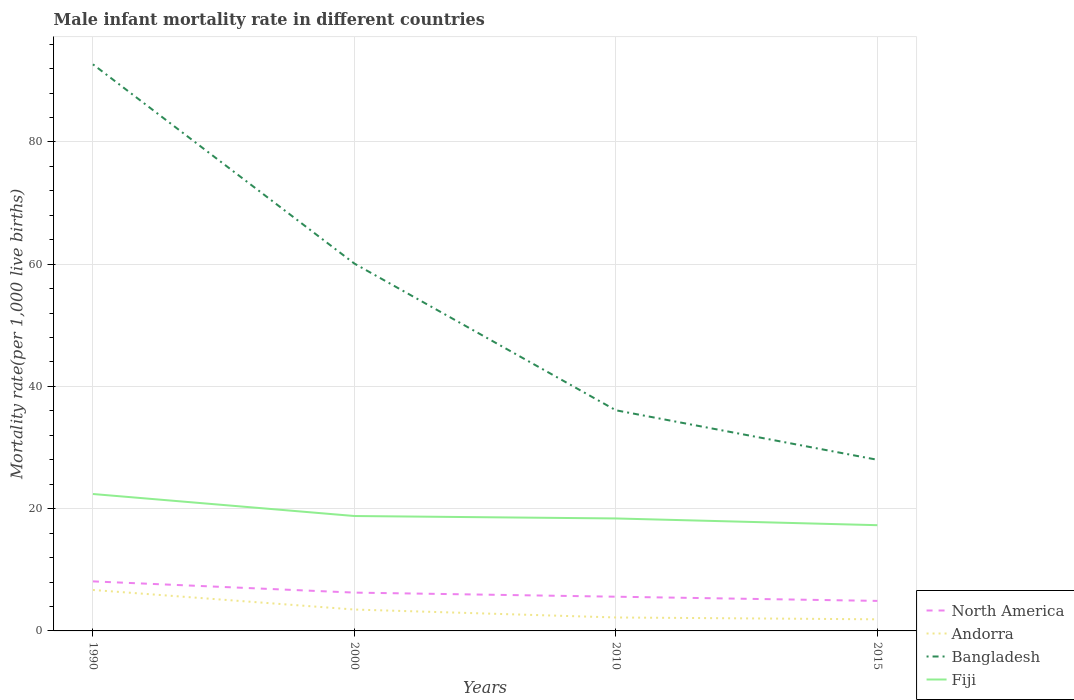Does the line corresponding to Fiji intersect with the line corresponding to Bangladesh?
Provide a succinct answer. No. In which year was the male infant mortality rate in Andorra maximum?
Keep it short and to the point. 2015. What is the total male infant mortality rate in Andorra in the graph?
Provide a succinct answer. 1.3. What is the difference between the highest and the second highest male infant mortality rate in Fiji?
Provide a short and direct response. 5.1. How many years are there in the graph?
Provide a short and direct response. 4. What is the title of the graph?
Keep it short and to the point. Male infant mortality rate in different countries. What is the label or title of the X-axis?
Offer a very short reply. Years. What is the label or title of the Y-axis?
Provide a short and direct response. Mortality rate(per 1,0 live births). What is the Mortality rate(per 1,000 live births) of North America in 1990?
Ensure brevity in your answer.  8.11. What is the Mortality rate(per 1,000 live births) of Bangladesh in 1990?
Ensure brevity in your answer.  92.7. What is the Mortality rate(per 1,000 live births) of Fiji in 1990?
Keep it short and to the point. 22.4. What is the Mortality rate(per 1,000 live births) in North America in 2000?
Give a very brief answer. 6.27. What is the Mortality rate(per 1,000 live births) of Andorra in 2000?
Offer a terse response. 3.5. What is the Mortality rate(per 1,000 live births) of Bangladesh in 2000?
Provide a succinct answer. 60.1. What is the Mortality rate(per 1,000 live births) in Fiji in 2000?
Your answer should be very brief. 18.8. What is the Mortality rate(per 1,000 live births) of North America in 2010?
Your answer should be compact. 5.6. What is the Mortality rate(per 1,000 live births) of Andorra in 2010?
Give a very brief answer. 2.2. What is the Mortality rate(per 1,000 live births) of Bangladesh in 2010?
Keep it short and to the point. 36.1. What is the Mortality rate(per 1,000 live births) in North America in 2015?
Your response must be concise. 4.91. What is the Mortality rate(per 1,000 live births) in Bangladesh in 2015?
Give a very brief answer. 28. What is the Mortality rate(per 1,000 live births) of Fiji in 2015?
Offer a terse response. 17.3. Across all years, what is the maximum Mortality rate(per 1,000 live births) of North America?
Provide a succinct answer. 8.11. Across all years, what is the maximum Mortality rate(per 1,000 live births) of Andorra?
Provide a short and direct response. 6.7. Across all years, what is the maximum Mortality rate(per 1,000 live births) in Bangladesh?
Offer a terse response. 92.7. Across all years, what is the maximum Mortality rate(per 1,000 live births) in Fiji?
Offer a very short reply. 22.4. Across all years, what is the minimum Mortality rate(per 1,000 live births) in North America?
Offer a very short reply. 4.91. Across all years, what is the minimum Mortality rate(per 1,000 live births) in Andorra?
Ensure brevity in your answer.  1.9. Across all years, what is the minimum Mortality rate(per 1,000 live births) in Bangladesh?
Keep it short and to the point. 28. What is the total Mortality rate(per 1,000 live births) of North America in the graph?
Keep it short and to the point. 24.89. What is the total Mortality rate(per 1,000 live births) of Bangladesh in the graph?
Make the answer very short. 216.9. What is the total Mortality rate(per 1,000 live births) of Fiji in the graph?
Offer a terse response. 76.9. What is the difference between the Mortality rate(per 1,000 live births) of North America in 1990 and that in 2000?
Provide a short and direct response. 1.84. What is the difference between the Mortality rate(per 1,000 live births) in Andorra in 1990 and that in 2000?
Offer a very short reply. 3.2. What is the difference between the Mortality rate(per 1,000 live births) of Bangladesh in 1990 and that in 2000?
Ensure brevity in your answer.  32.6. What is the difference between the Mortality rate(per 1,000 live births) in North America in 1990 and that in 2010?
Offer a very short reply. 2.51. What is the difference between the Mortality rate(per 1,000 live births) in Andorra in 1990 and that in 2010?
Your answer should be compact. 4.5. What is the difference between the Mortality rate(per 1,000 live births) of Bangladesh in 1990 and that in 2010?
Provide a short and direct response. 56.6. What is the difference between the Mortality rate(per 1,000 live births) in North America in 1990 and that in 2015?
Ensure brevity in your answer.  3.19. What is the difference between the Mortality rate(per 1,000 live births) in Bangladesh in 1990 and that in 2015?
Offer a very short reply. 64.7. What is the difference between the Mortality rate(per 1,000 live births) of North America in 2000 and that in 2010?
Give a very brief answer. 0.67. What is the difference between the Mortality rate(per 1,000 live births) of Andorra in 2000 and that in 2010?
Provide a succinct answer. 1.3. What is the difference between the Mortality rate(per 1,000 live births) in Bangladesh in 2000 and that in 2010?
Make the answer very short. 24. What is the difference between the Mortality rate(per 1,000 live births) of Fiji in 2000 and that in 2010?
Offer a terse response. 0.4. What is the difference between the Mortality rate(per 1,000 live births) of North America in 2000 and that in 2015?
Keep it short and to the point. 1.36. What is the difference between the Mortality rate(per 1,000 live births) in Andorra in 2000 and that in 2015?
Provide a succinct answer. 1.6. What is the difference between the Mortality rate(per 1,000 live births) in Bangladesh in 2000 and that in 2015?
Your answer should be very brief. 32.1. What is the difference between the Mortality rate(per 1,000 live births) of North America in 2010 and that in 2015?
Offer a very short reply. 0.69. What is the difference between the Mortality rate(per 1,000 live births) in Andorra in 2010 and that in 2015?
Your answer should be very brief. 0.3. What is the difference between the Mortality rate(per 1,000 live births) of North America in 1990 and the Mortality rate(per 1,000 live births) of Andorra in 2000?
Your response must be concise. 4.61. What is the difference between the Mortality rate(per 1,000 live births) of North America in 1990 and the Mortality rate(per 1,000 live births) of Bangladesh in 2000?
Ensure brevity in your answer.  -51.99. What is the difference between the Mortality rate(per 1,000 live births) in North America in 1990 and the Mortality rate(per 1,000 live births) in Fiji in 2000?
Make the answer very short. -10.69. What is the difference between the Mortality rate(per 1,000 live births) of Andorra in 1990 and the Mortality rate(per 1,000 live births) of Bangladesh in 2000?
Provide a succinct answer. -53.4. What is the difference between the Mortality rate(per 1,000 live births) of Bangladesh in 1990 and the Mortality rate(per 1,000 live births) of Fiji in 2000?
Offer a very short reply. 73.9. What is the difference between the Mortality rate(per 1,000 live births) in North America in 1990 and the Mortality rate(per 1,000 live births) in Andorra in 2010?
Your answer should be compact. 5.91. What is the difference between the Mortality rate(per 1,000 live births) in North America in 1990 and the Mortality rate(per 1,000 live births) in Bangladesh in 2010?
Offer a terse response. -27.99. What is the difference between the Mortality rate(per 1,000 live births) of North America in 1990 and the Mortality rate(per 1,000 live births) of Fiji in 2010?
Keep it short and to the point. -10.29. What is the difference between the Mortality rate(per 1,000 live births) in Andorra in 1990 and the Mortality rate(per 1,000 live births) in Bangladesh in 2010?
Provide a short and direct response. -29.4. What is the difference between the Mortality rate(per 1,000 live births) of Andorra in 1990 and the Mortality rate(per 1,000 live births) of Fiji in 2010?
Your answer should be compact. -11.7. What is the difference between the Mortality rate(per 1,000 live births) in Bangladesh in 1990 and the Mortality rate(per 1,000 live births) in Fiji in 2010?
Provide a succinct answer. 74.3. What is the difference between the Mortality rate(per 1,000 live births) of North America in 1990 and the Mortality rate(per 1,000 live births) of Andorra in 2015?
Provide a succinct answer. 6.21. What is the difference between the Mortality rate(per 1,000 live births) of North America in 1990 and the Mortality rate(per 1,000 live births) of Bangladesh in 2015?
Make the answer very short. -19.89. What is the difference between the Mortality rate(per 1,000 live births) of North America in 1990 and the Mortality rate(per 1,000 live births) of Fiji in 2015?
Give a very brief answer. -9.19. What is the difference between the Mortality rate(per 1,000 live births) of Andorra in 1990 and the Mortality rate(per 1,000 live births) of Bangladesh in 2015?
Make the answer very short. -21.3. What is the difference between the Mortality rate(per 1,000 live births) in Andorra in 1990 and the Mortality rate(per 1,000 live births) in Fiji in 2015?
Provide a short and direct response. -10.6. What is the difference between the Mortality rate(per 1,000 live births) of Bangladesh in 1990 and the Mortality rate(per 1,000 live births) of Fiji in 2015?
Provide a succinct answer. 75.4. What is the difference between the Mortality rate(per 1,000 live births) in North America in 2000 and the Mortality rate(per 1,000 live births) in Andorra in 2010?
Make the answer very short. 4.07. What is the difference between the Mortality rate(per 1,000 live births) in North America in 2000 and the Mortality rate(per 1,000 live births) in Bangladesh in 2010?
Make the answer very short. -29.83. What is the difference between the Mortality rate(per 1,000 live births) of North America in 2000 and the Mortality rate(per 1,000 live births) of Fiji in 2010?
Offer a very short reply. -12.13. What is the difference between the Mortality rate(per 1,000 live births) of Andorra in 2000 and the Mortality rate(per 1,000 live births) of Bangladesh in 2010?
Your answer should be very brief. -32.6. What is the difference between the Mortality rate(per 1,000 live births) of Andorra in 2000 and the Mortality rate(per 1,000 live births) of Fiji in 2010?
Your answer should be very brief. -14.9. What is the difference between the Mortality rate(per 1,000 live births) in Bangladesh in 2000 and the Mortality rate(per 1,000 live births) in Fiji in 2010?
Offer a very short reply. 41.7. What is the difference between the Mortality rate(per 1,000 live births) in North America in 2000 and the Mortality rate(per 1,000 live births) in Andorra in 2015?
Make the answer very short. 4.37. What is the difference between the Mortality rate(per 1,000 live births) in North America in 2000 and the Mortality rate(per 1,000 live births) in Bangladesh in 2015?
Give a very brief answer. -21.73. What is the difference between the Mortality rate(per 1,000 live births) of North America in 2000 and the Mortality rate(per 1,000 live births) of Fiji in 2015?
Keep it short and to the point. -11.03. What is the difference between the Mortality rate(per 1,000 live births) of Andorra in 2000 and the Mortality rate(per 1,000 live births) of Bangladesh in 2015?
Ensure brevity in your answer.  -24.5. What is the difference between the Mortality rate(per 1,000 live births) of Bangladesh in 2000 and the Mortality rate(per 1,000 live births) of Fiji in 2015?
Give a very brief answer. 42.8. What is the difference between the Mortality rate(per 1,000 live births) in North America in 2010 and the Mortality rate(per 1,000 live births) in Andorra in 2015?
Your answer should be very brief. 3.7. What is the difference between the Mortality rate(per 1,000 live births) in North America in 2010 and the Mortality rate(per 1,000 live births) in Bangladesh in 2015?
Keep it short and to the point. -22.4. What is the difference between the Mortality rate(per 1,000 live births) in North America in 2010 and the Mortality rate(per 1,000 live births) in Fiji in 2015?
Your response must be concise. -11.7. What is the difference between the Mortality rate(per 1,000 live births) of Andorra in 2010 and the Mortality rate(per 1,000 live births) of Bangladesh in 2015?
Your answer should be very brief. -25.8. What is the difference between the Mortality rate(per 1,000 live births) in Andorra in 2010 and the Mortality rate(per 1,000 live births) in Fiji in 2015?
Your answer should be compact. -15.1. What is the difference between the Mortality rate(per 1,000 live births) in Bangladesh in 2010 and the Mortality rate(per 1,000 live births) in Fiji in 2015?
Provide a short and direct response. 18.8. What is the average Mortality rate(per 1,000 live births) in North America per year?
Keep it short and to the point. 6.22. What is the average Mortality rate(per 1,000 live births) of Andorra per year?
Offer a very short reply. 3.58. What is the average Mortality rate(per 1,000 live births) of Bangladesh per year?
Offer a terse response. 54.23. What is the average Mortality rate(per 1,000 live births) of Fiji per year?
Make the answer very short. 19.23. In the year 1990, what is the difference between the Mortality rate(per 1,000 live births) of North America and Mortality rate(per 1,000 live births) of Andorra?
Provide a succinct answer. 1.41. In the year 1990, what is the difference between the Mortality rate(per 1,000 live births) of North America and Mortality rate(per 1,000 live births) of Bangladesh?
Offer a terse response. -84.59. In the year 1990, what is the difference between the Mortality rate(per 1,000 live births) of North America and Mortality rate(per 1,000 live births) of Fiji?
Your answer should be compact. -14.29. In the year 1990, what is the difference between the Mortality rate(per 1,000 live births) of Andorra and Mortality rate(per 1,000 live births) of Bangladesh?
Keep it short and to the point. -86. In the year 1990, what is the difference between the Mortality rate(per 1,000 live births) in Andorra and Mortality rate(per 1,000 live births) in Fiji?
Ensure brevity in your answer.  -15.7. In the year 1990, what is the difference between the Mortality rate(per 1,000 live births) of Bangladesh and Mortality rate(per 1,000 live births) of Fiji?
Ensure brevity in your answer.  70.3. In the year 2000, what is the difference between the Mortality rate(per 1,000 live births) of North America and Mortality rate(per 1,000 live births) of Andorra?
Make the answer very short. 2.77. In the year 2000, what is the difference between the Mortality rate(per 1,000 live births) in North America and Mortality rate(per 1,000 live births) in Bangladesh?
Keep it short and to the point. -53.83. In the year 2000, what is the difference between the Mortality rate(per 1,000 live births) of North America and Mortality rate(per 1,000 live births) of Fiji?
Your response must be concise. -12.53. In the year 2000, what is the difference between the Mortality rate(per 1,000 live births) in Andorra and Mortality rate(per 1,000 live births) in Bangladesh?
Your answer should be compact. -56.6. In the year 2000, what is the difference between the Mortality rate(per 1,000 live births) in Andorra and Mortality rate(per 1,000 live births) in Fiji?
Make the answer very short. -15.3. In the year 2000, what is the difference between the Mortality rate(per 1,000 live births) in Bangladesh and Mortality rate(per 1,000 live births) in Fiji?
Offer a very short reply. 41.3. In the year 2010, what is the difference between the Mortality rate(per 1,000 live births) in North America and Mortality rate(per 1,000 live births) in Andorra?
Your answer should be compact. 3.4. In the year 2010, what is the difference between the Mortality rate(per 1,000 live births) of North America and Mortality rate(per 1,000 live births) of Bangladesh?
Your answer should be compact. -30.5. In the year 2010, what is the difference between the Mortality rate(per 1,000 live births) of North America and Mortality rate(per 1,000 live births) of Fiji?
Make the answer very short. -12.8. In the year 2010, what is the difference between the Mortality rate(per 1,000 live births) of Andorra and Mortality rate(per 1,000 live births) of Bangladesh?
Offer a very short reply. -33.9. In the year 2010, what is the difference between the Mortality rate(per 1,000 live births) in Andorra and Mortality rate(per 1,000 live births) in Fiji?
Your answer should be compact. -16.2. In the year 2015, what is the difference between the Mortality rate(per 1,000 live births) in North America and Mortality rate(per 1,000 live births) in Andorra?
Your answer should be very brief. 3.01. In the year 2015, what is the difference between the Mortality rate(per 1,000 live births) of North America and Mortality rate(per 1,000 live births) of Bangladesh?
Provide a short and direct response. -23.09. In the year 2015, what is the difference between the Mortality rate(per 1,000 live births) in North America and Mortality rate(per 1,000 live births) in Fiji?
Ensure brevity in your answer.  -12.39. In the year 2015, what is the difference between the Mortality rate(per 1,000 live births) in Andorra and Mortality rate(per 1,000 live births) in Bangladesh?
Offer a terse response. -26.1. In the year 2015, what is the difference between the Mortality rate(per 1,000 live births) in Andorra and Mortality rate(per 1,000 live births) in Fiji?
Your answer should be very brief. -15.4. What is the ratio of the Mortality rate(per 1,000 live births) of North America in 1990 to that in 2000?
Your answer should be compact. 1.29. What is the ratio of the Mortality rate(per 1,000 live births) in Andorra in 1990 to that in 2000?
Offer a terse response. 1.91. What is the ratio of the Mortality rate(per 1,000 live births) of Bangladesh in 1990 to that in 2000?
Provide a succinct answer. 1.54. What is the ratio of the Mortality rate(per 1,000 live births) of Fiji in 1990 to that in 2000?
Offer a very short reply. 1.19. What is the ratio of the Mortality rate(per 1,000 live births) in North America in 1990 to that in 2010?
Ensure brevity in your answer.  1.45. What is the ratio of the Mortality rate(per 1,000 live births) in Andorra in 1990 to that in 2010?
Offer a very short reply. 3.05. What is the ratio of the Mortality rate(per 1,000 live births) in Bangladesh in 1990 to that in 2010?
Keep it short and to the point. 2.57. What is the ratio of the Mortality rate(per 1,000 live births) in Fiji in 1990 to that in 2010?
Keep it short and to the point. 1.22. What is the ratio of the Mortality rate(per 1,000 live births) of North America in 1990 to that in 2015?
Provide a succinct answer. 1.65. What is the ratio of the Mortality rate(per 1,000 live births) in Andorra in 1990 to that in 2015?
Offer a terse response. 3.53. What is the ratio of the Mortality rate(per 1,000 live births) in Bangladesh in 1990 to that in 2015?
Offer a very short reply. 3.31. What is the ratio of the Mortality rate(per 1,000 live births) of Fiji in 1990 to that in 2015?
Provide a succinct answer. 1.29. What is the ratio of the Mortality rate(per 1,000 live births) in North America in 2000 to that in 2010?
Keep it short and to the point. 1.12. What is the ratio of the Mortality rate(per 1,000 live births) in Andorra in 2000 to that in 2010?
Offer a very short reply. 1.59. What is the ratio of the Mortality rate(per 1,000 live births) of Bangladesh in 2000 to that in 2010?
Your answer should be very brief. 1.66. What is the ratio of the Mortality rate(per 1,000 live births) in Fiji in 2000 to that in 2010?
Give a very brief answer. 1.02. What is the ratio of the Mortality rate(per 1,000 live births) in North America in 2000 to that in 2015?
Provide a short and direct response. 1.28. What is the ratio of the Mortality rate(per 1,000 live births) in Andorra in 2000 to that in 2015?
Give a very brief answer. 1.84. What is the ratio of the Mortality rate(per 1,000 live births) of Bangladesh in 2000 to that in 2015?
Ensure brevity in your answer.  2.15. What is the ratio of the Mortality rate(per 1,000 live births) in Fiji in 2000 to that in 2015?
Give a very brief answer. 1.09. What is the ratio of the Mortality rate(per 1,000 live births) of North America in 2010 to that in 2015?
Provide a short and direct response. 1.14. What is the ratio of the Mortality rate(per 1,000 live births) in Andorra in 2010 to that in 2015?
Provide a succinct answer. 1.16. What is the ratio of the Mortality rate(per 1,000 live births) in Bangladesh in 2010 to that in 2015?
Your response must be concise. 1.29. What is the ratio of the Mortality rate(per 1,000 live births) of Fiji in 2010 to that in 2015?
Ensure brevity in your answer.  1.06. What is the difference between the highest and the second highest Mortality rate(per 1,000 live births) in North America?
Offer a very short reply. 1.84. What is the difference between the highest and the second highest Mortality rate(per 1,000 live births) in Andorra?
Ensure brevity in your answer.  3.2. What is the difference between the highest and the second highest Mortality rate(per 1,000 live births) in Bangladesh?
Offer a terse response. 32.6. What is the difference between the highest and the second highest Mortality rate(per 1,000 live births) in Fiji?
Give a very brief answer. 3.6. What is the difference between the highest and the lowest Mortality rate(per 1,000 live births) in North America?
Make the answer very short. 3.19. What is the difference between the highest and the lowest Mortality rate(per 1,000 live births) of Bangladesh?
Your response must be concise. 64.7. What is the difference between the highest and the lowest Mortality rate(per 1,000 live births) of Fiji?
Offer a very short reply. 5.1. 